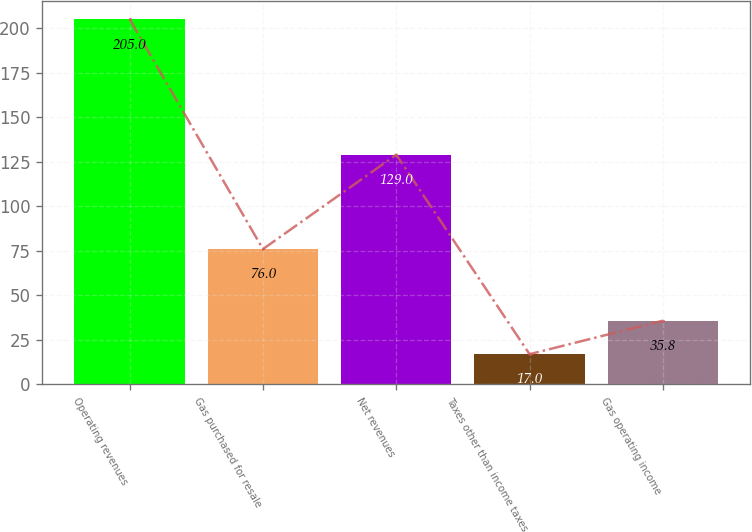<chart> <loc_0><loc_0><loc_500><loc_500><bar_chart><fcel>Operating revenues<fcel>Gas purchased for resale<fcel>Net revenues<fcel>Taxes other than income taxes<fcel>Gas operating income<nl><fcel>205<fcel>76<fcel>129<fcel>17<fcel>35.8<nl></chart> 